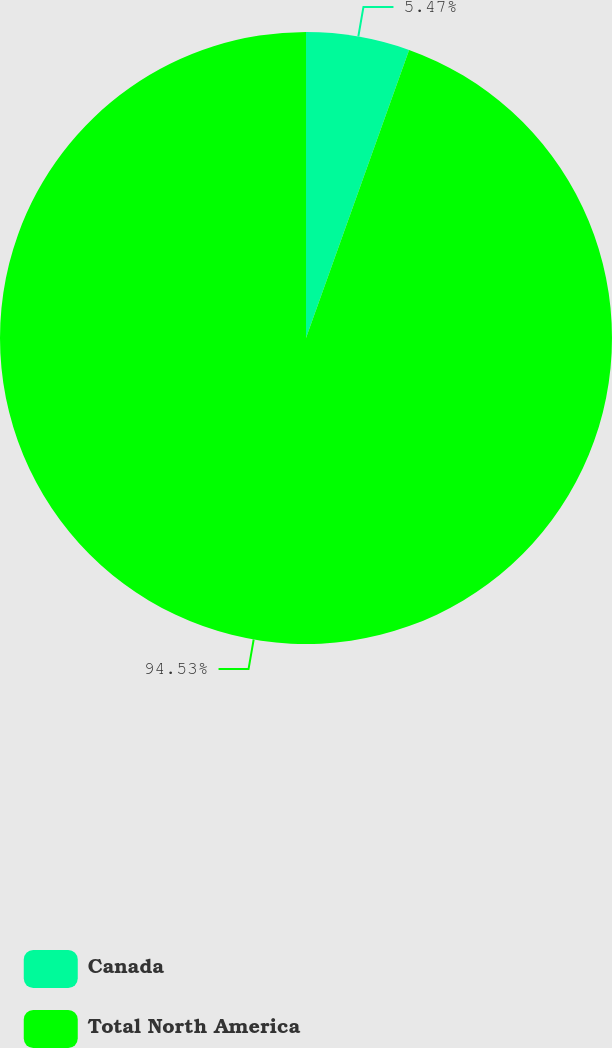Convert chart to OTSL. <chart><loc_0><loc_0><loc_500><loc_500><pie_chart><fcel>Canada<fcel>Total North America<nl><fcel>5.47%<fcel>94.53%<nl></chart> 